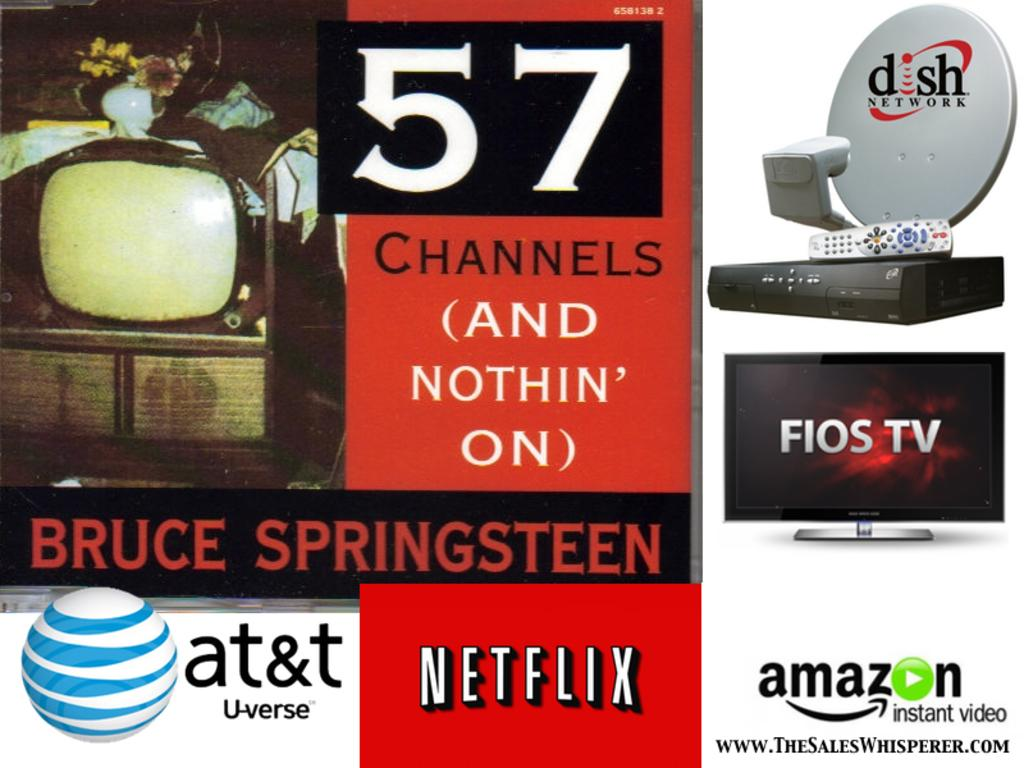<image>
Present a compact description of the photo's key features. a Netflix sign that is around many other ones 